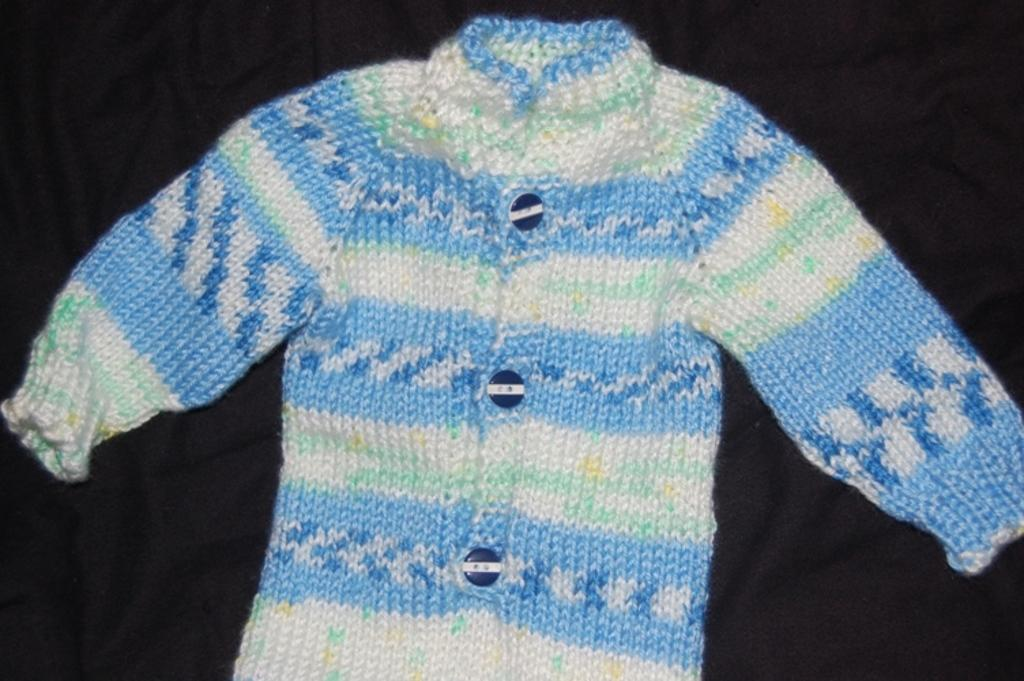What type of clothing is visible in the image? There is a woolen sweater in the image. What is the sweater placed on in the image? The woolen sweater is on a black cloth. What type of attraction can be seen in the image? There is no attraction present in the image; it features a woolen sweater on a black cloth. What type of comb is used to style the sweater in the image? There is no comb present in the image, and the sweater is not styled in any particular way. 